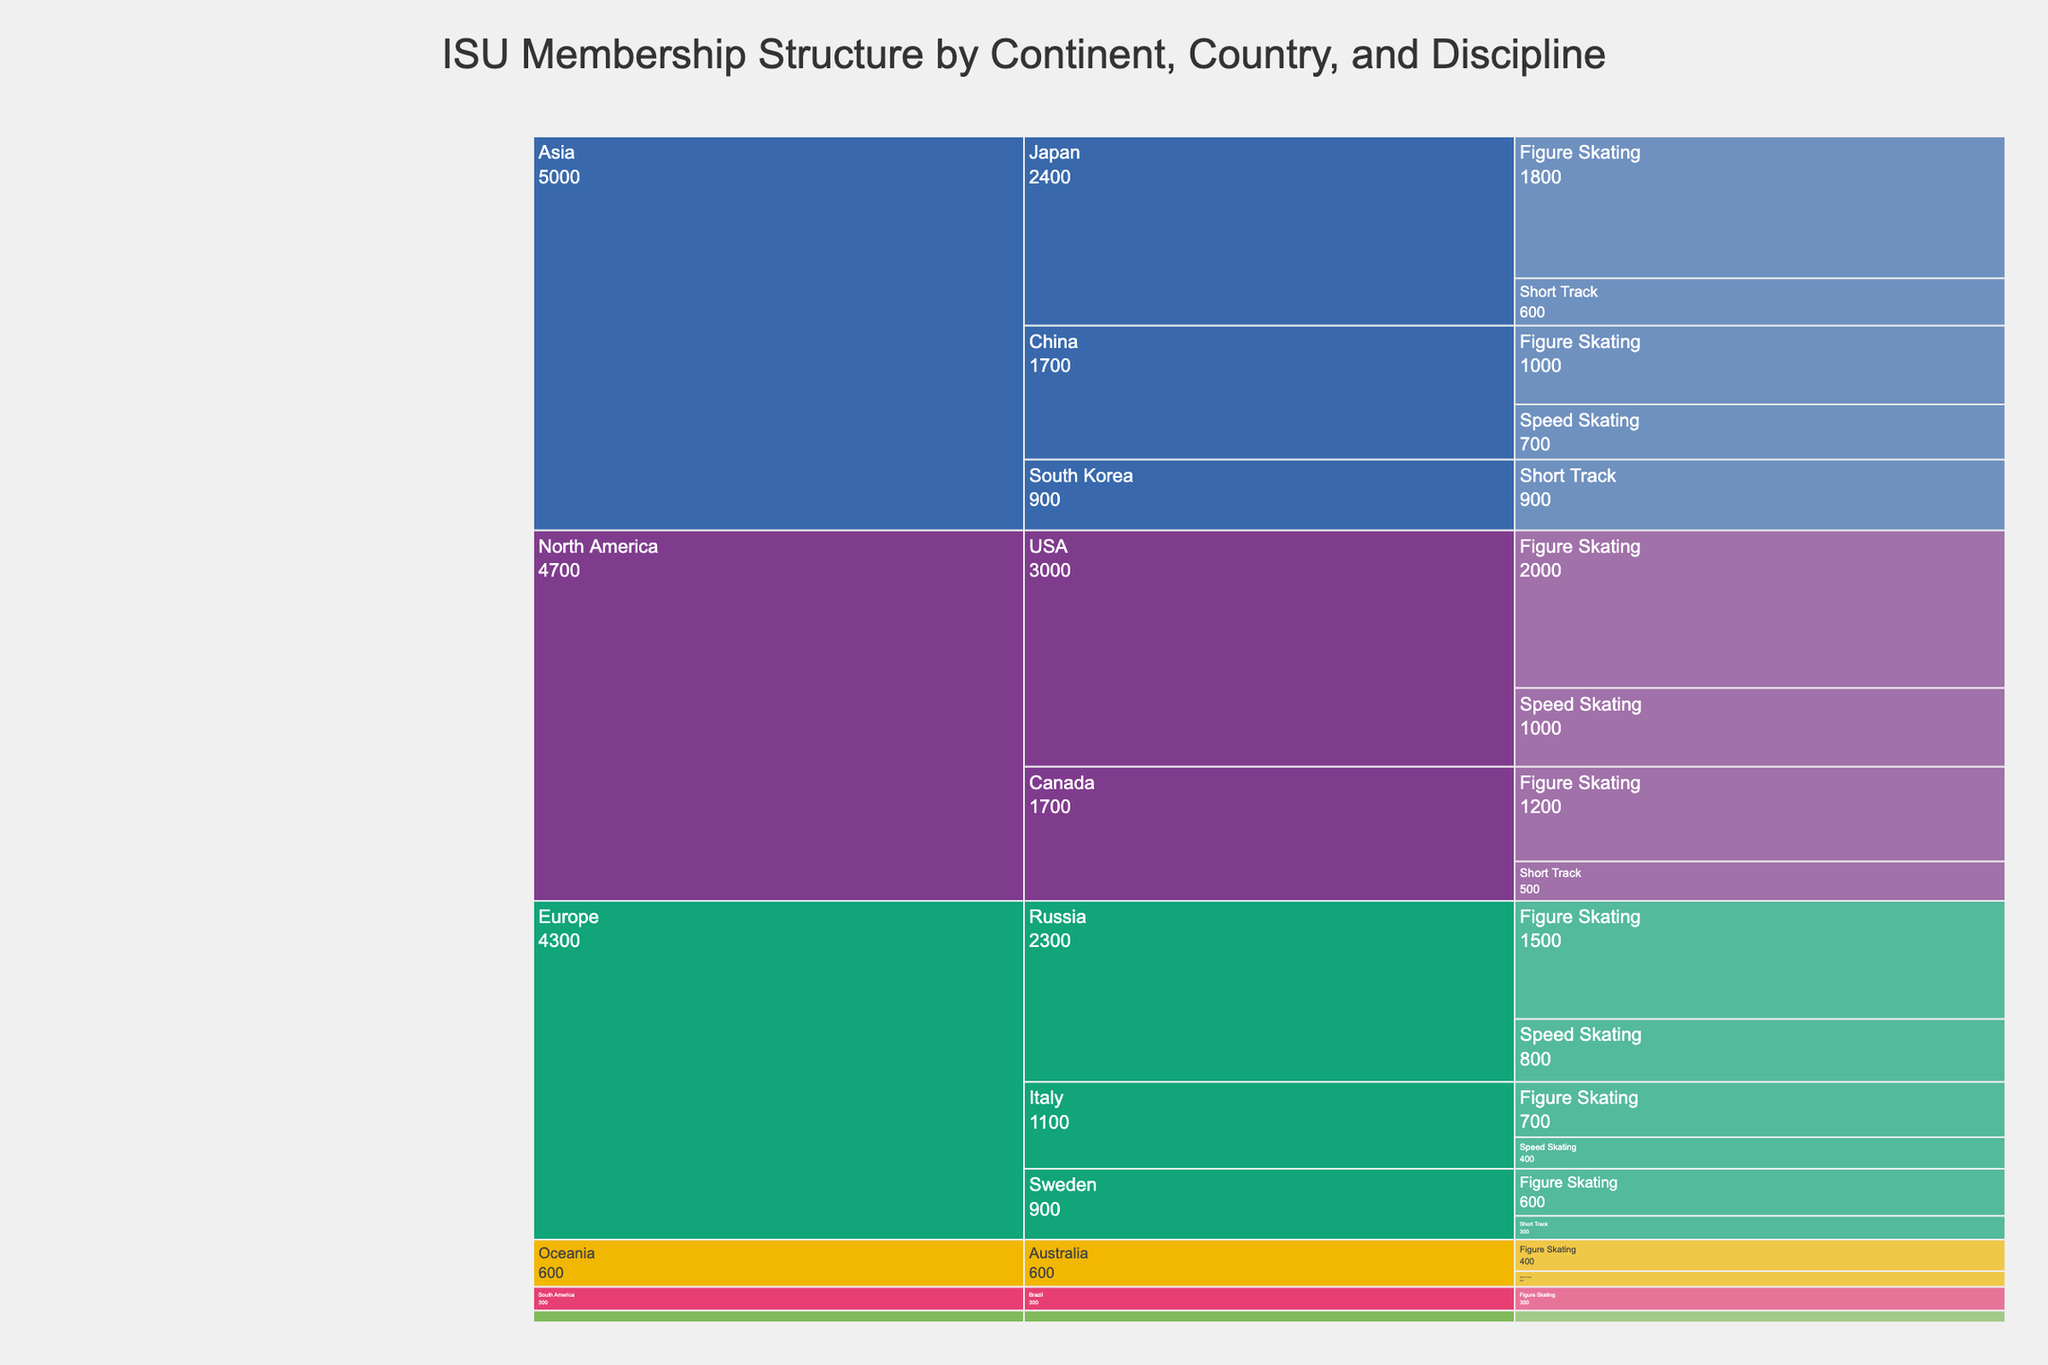What is the title of the chart? The title can typically be found at the top of the chart and visually separates it from the rest of the chart data. It provides a high-level summary of what the chart represents. In this case, it is clearly stated at the top.
Answer: ISU Membership Structure by Continent, Country, and Discipline Which continent has the highest number of members? To find the answer, examine the icicle chart and identify the continent with the largest segment by value. Summing the member counts for each continent section: 
Europe (1500 + 800 + 600 + 300 + 700 + 400 = 4300), North America (1200 + 500 + 2000 + 1000 = 4700), Asia (1800 + 600 + 900 + 1000 + 700 = 5000), Oceania (400 + 200 = 600), South America (300), Africa (150)
Answer: Asia How many members are associated with figure skating in North America? Sum the values of members in North America who are in the discipline of figure skating. From the chart, the USA has 2000 members, and Canada has 1200. Adding them up: 2000 (USA) + 1200 (Canada)
Answer: 3200 Which country in Europe has the most members in speed skating? To determine this, check each European country's segment in the icicle chart for speed skating and compare their values. For Europe: Russia (800), Italy (400). Among these, Russia has the most members.
Answer: Russia How many members belong to short track skating in Asia? Sum the values of all short track skating members in Asia based on the chart. The relevant countries are Japan (600) and South Korea (900). Adding them: 600 (Japan) + 900 (South Korea)
Answer: 1500 Which discipline has the least number of members in Oceania? Compare the segment sizes of the disciplines under Oceania in the icicle chart and look for the smallest value. Oceania shows: Figure Skating (400), Short Track (200)—Short Track is the smallest.
Answer: Short Track What is the total number of members in Figure Skating across all continents? Add up the values of Figure Skating members from all continents visible in the chart: Europe (1500 + 600 + 700 = 2800), North America (1200 + 2000 = 3200), Asia (1800 + 1000 = 2800), Oceania (400), South America (300), Africa (150). Summing these gives: 2800 + 3200 + 2800 + 400 + 300 + 150
Answer: 9650 Which discipline has the most members in Japan? Examine the segment sizes for disciplines under Japan in the icicle chart. Japan has Figure Skating (1800), Short Track (600). Figure Skating has the most members.
Answer: Figure Skating Is the membership count for speed skating greater in Canada or Australia? Compare the values for speed skating in Canada (1000) and Australia (no entry for speed skating, implying 0). Therefore, Canada's value is greater.
Answer: Canada 